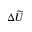<formula> <loc_0><loc_0><loc_500><loc_500>\Delta \widetilde { U }</formula> 